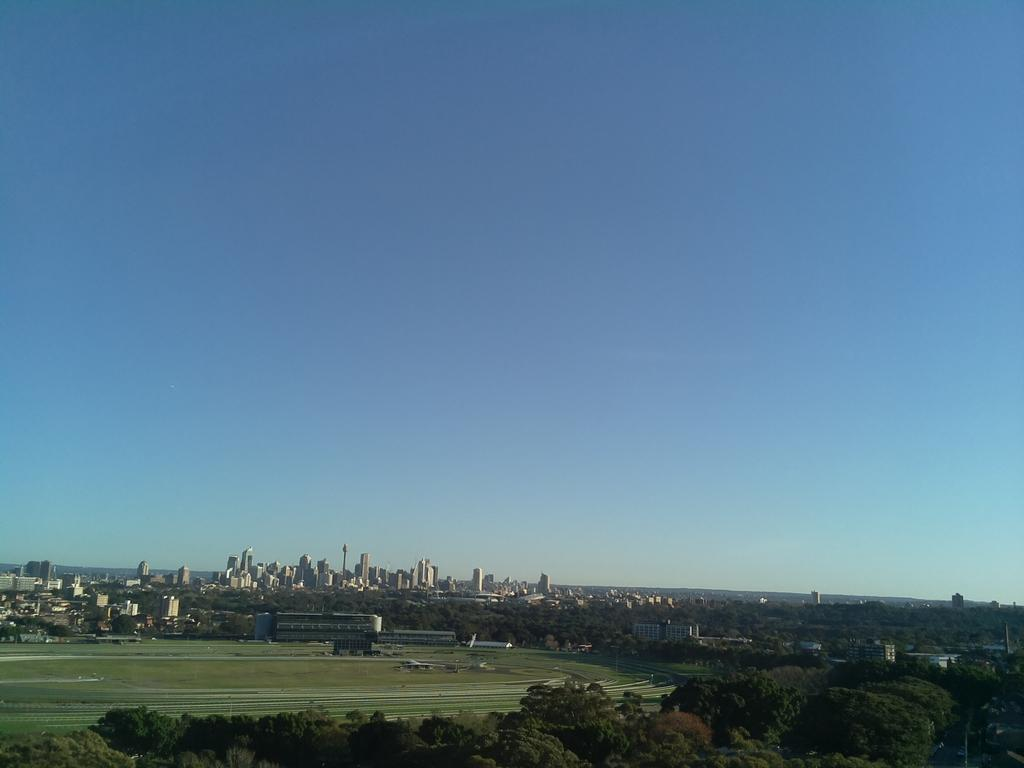Where was the picture taken? The picture was clicked outside. What can be seen in the foreground of the image? There is grass and trees in the foreground. What is visible in the background of the image? The sky, skyscrapers, and other buildings are visible in the background. Can you describe the natural elements in the foreground? The foreground consists of grass and trees. What is the title of the book that the chickens are reading in the image? There are no chickens or books present in the image. What type of trail can be seen in the image? There is no trail visible in the image. 